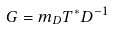<formula> <loc_0><loc_0><loc_500><loc_500>G = m _ { D } T ^ { * } D ^ { - 1 }</formula> 